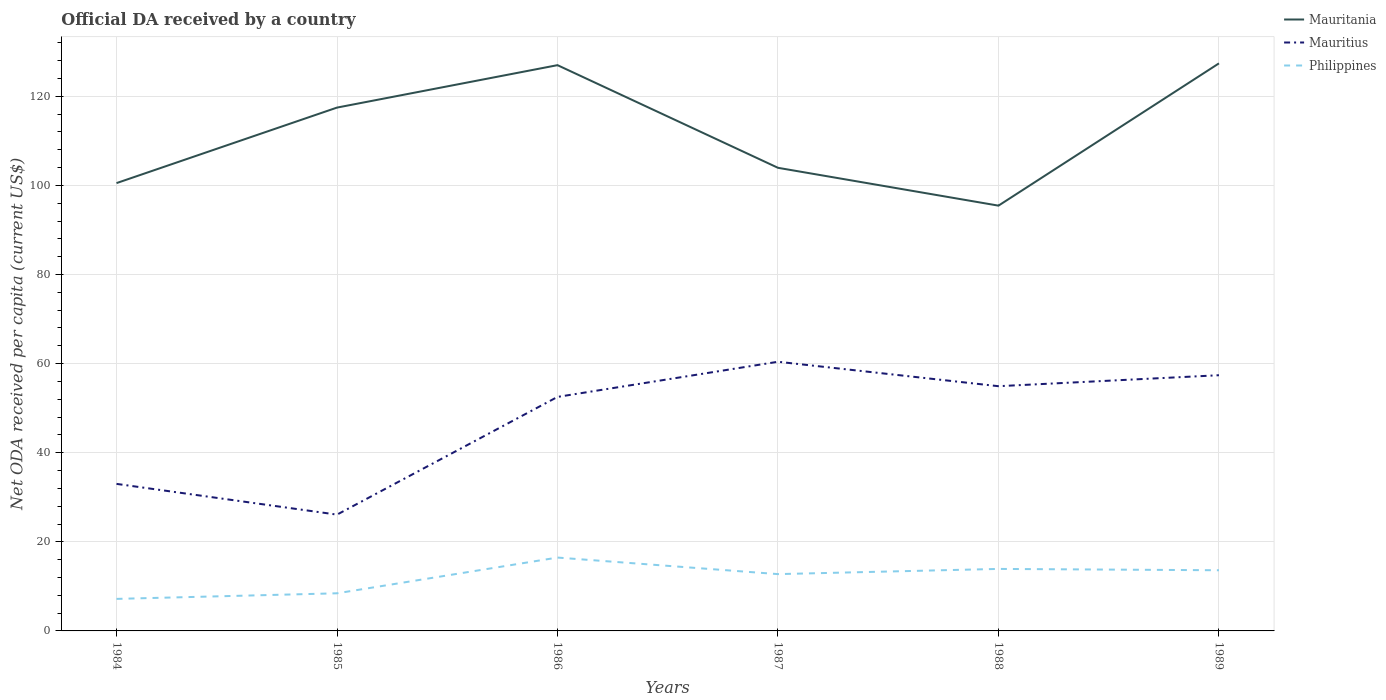Is the number of lines equal to the number of legend labels?
Ensure brevity in your answer.  Yes. Across all years, what is the maximum ODA received in in Mauritius?
Offer a terse response. 26.1. In which year was the ODA received in in Mauritius maximum?
Make the answer very short. 1985. What is the total ODA received in in Mauritius in the graph?
Provide a short and direct response. -31.29. What is the difference between the highest and the second highest ODA received in in Mauritania?
Ensure brevity in your answer.  31.94. How many years are there in the graph?
Give a very brief answer. 6. Are the values on the major ticks of Y-axis written in scientific E-notation?
Provide a short and direct response. No. Where does the legend appear in the graph?
Offer a terse response. Top right. How many legend labels are there?
Make the answer very short. 3. How are the legend labels stacked?
Your answer should be very brief. Vertical. What is the title of the graph?
Give a very brief answer. Official DA received by a country. What is the label or title of the X-axis?
Offer a terse response. Years. What is the label or title of the Y-axis?
Give a very brief answer. Net ODA received per capita (current US$). What is the Net ODA received per capita (current US$) in Mauritania in 1984?
Ensure brevity in your answer.  100.52. What is the Net ODA received per capita (current US$) of Mauritius in 1984?
Give a very brief answer. 33.01. What is the Net ODA received per capita (current US$) of Philippines in 1984?
Your answer should be compact. 7.19. What is the Net ODA received per capita (current US$) of Mauritania in 1985?
Give a very brief answer. 117.47. What is the Net ODA received per capita (current US$) in Mauritius in 1985?
Ensure brevity in your answer.  26.1. What is the Net ODA received per capita (current US$) of Philippines in 1985?
Offer a terse response. 8.45. What is the Net ODA received per capita (current US$) of Mauritania in 1986?
Your answer should be compact. 127. What is the Net ODA received per capita (current US$) of Mauritius in 1986?
Provide a short and direct response. 52.53. What is the Net ODA received per capita (current US$) in Philippines in 1986?
Your answer should be compact. 16.47. What is the Net ODA received per capita (current US$) of Mauritania in 1987?
Give a very brief answer. 103.95. What is the Net ODA received per capita (current US$) of Mauritius in 1987?
Provide a short and direct response. 60.42. What is the Net ODA received per capita (current US$) of Philippines in 1987?
Ensure brevity in your answer.  12.75. What is the Net ODA received per capita (current US$) of Mauritania in 1988?
Your answer should be compact. 95.46. What is the Net ODA received per capita (current US$) of Mauritius in 1988?
Give a very brief answer. 54.93. What is the Net ODA received per capita (current US$) of Philippines in 1988?
Provide a succinct answer. 13.92. What is the Net ODA received per capita (current US$) of Mauritania in 1989?
Your answer should be compact. 127.4. What is the Net ODA received per capita (current US$) in Mauritius in 1989?
Make the answer very short. 57.4. What is the Net ODA received per capita (current US$) in Philippines in 1989?
Your response must be concise. 13.62. Across all years, what is the maximum Net ODA received per capita (current US$) in Mauritania?
Provide a short and direct response. 127.4. Across all years, what is the maximum Net ODA received per capita (current US$) in Mauritius?
Offer a terse response. 60.42. Across all years, what is the maximum Net ODA received per capita (current US$) in Philippines?
Offer a very short reply. 16.47. Across all years, what is the minimum Net ODA received per capita (current US$) of Mauritania?
Offer a terse response. 95.46. Across all years, what is the minimum Net ODA received per capita (current US$) of Mauritius?
Your answer should be compact. 26.1. Across all years, what is the minimum Net ODA received per capita (current US$) in Philippines?
Your answer should be very brief. 7.19. What is the total Net ODA received per capita (current US$) of Mauritania in the graph?
Provide a short and direct response. 671.81. What is the total Net ODA received per capita (current US$) in Mauritius in the graph?
Give a very brief answer. 284.39. What is the total Net ODA received per capita (current US$) of Philippines in the graph?
Your answer should be compact. 72.39. What is the difference between the Net ODA received per capita (current US$) in Mauritania in 1984 and that in 1985?
Your answer should be compact. -16.95. What is the difference between the Net ODA received per capita (current US$) of Mauritius in 1984 and that in 1985?
Offer a very short reply. 6.9. What is the difference between the Net ODA received per capita (current US$) in Philippines in 1984 and that in 1985?
Offer a very short reply. -1.26. What is the difference between the Net ODA received per capita (current US$) of Mauritania in 1984 and that in 1986?
Make the answer very short. -26.48. What is the difference between the Net ODA received per capita (current US$) of Mauritius in 1984 and that in 1986?
Ensure brevity in your answer.  -19.52. What is the difference between the Net ODA received per capita (current US$) in Philippines in 1984 and that in 1986?
Give a very brief answer. -9.28. What is the difference between the Net ODA received per capita (current US$) in Mauritania in 1984 and that in 1987?
Make the answer very short. -3.43. What is the difference between the Net ODA received per capita (current US$) in Mauritius in 1984 and that in 1987?
Give a very brief answer. -27.41. What is the difference between the Net ODA received per capita (current US$) in Philippines in 1984 and that in 1987?
Keep it short and to the point. -5.56. What is the difference between the Net ODA received per capita (current US$) of Mauritania in 1984 and that in 1988?
Offer a terse response. 5.06. What is the difference between the Net ODA received per capita (current US$) in Mauritius in 1984 and that in 1988?
Provide a succinct answer. -21.93. What is the difference between the Net ODA received per capita (current US$) of Philippines in 1984 and that in 1988?
Give a very brief answer. -6.73. What is the difference between the Net ODA received per capita (current US$) in Mauritania in 1984 and that in 1989?
Make the answer very short. -26.88. What is the difference between the Net ODA received per capita (current US$) in Mauritius in 1984 and that in 1989?
Your answer should be very brief. -24.39. What is the difference between the Net ODA received per capita (current US$) of Philippines in 1984 and that in 1989?
Provide a succinct answer. -6.43. What is the difference between the Net ODA received per capita (current US$) in Mauritania in 1985 and that in 1986?
Your response must be concise. -9.52. What is the difference between the Net ODA received per capita (current US$) of Mauritius in 1985 and that in 1986?
Provide a short and direct response. -26.43. What is the difference between the Net ODA received per capita (current US$) of Philippines in 1985 and that in 1986?
Provide a succinct answer. -8.02. What is the difference between the Net ODA received per capita (current US$) in Mauritania in 1985 and that in 1987?
Your answer should be compact. 13.52. What is the difference between the Net ODA received per capita (current US$) in Mauritius in 1985 and that in 1987?
Your response must be concise. -34.32. What is the difference between the Net ODA received per capita (current US$) of Philippines in 1985 and that in 1987?
Your answer should be very brief. -4.31. What is the difference between the Net ODA received per capita (current US$) of Mauritania in 1985 and that in 1988?
Provide a succinct answer. 22.01. What is the difference between the Net ODA received per capita (current US$) in Mauritius in 1985 and that in 1988?
Offer a terse response. -28.83. What is the difference between the Net ODA received per capita (current US$) of Philippines in 1985 and that in 1988?
Make the answer very short. -5.47. What is the difference between the Net ODA received per capita (current US$) in Mauritania in 1985 and that in 1989?
Keep it short and to the point. -9.93. What is the difference between the Net ODA received per capita (current US$) in Mauritius in 1985 and that in 1989?
Make the answer very short. -31.29. What is the difference between the Net ODA received per capita (current US$) in Philippines in 1985 and that in 1989?
Give a very brief answer. -5.17. What is the difference between the Net ODA received per capita (current US$) of Mauritania in 1986 and that in 1987?
Offer a terse response. 23.05. What is the difference between the Net ODA received per capita (current US$) in Mauritius in 1986 and that in 1987?
Offer a very short reply. -7.89. What is the difference between the Net ODA received per capita (current US$) of Philippines in 1986 and that in 1987?
Offer a terse response. 3.72. What is the difference between the Net ODA received per capita (current US$) of Mauritania in 1986 and that in 1988?
Your answer should be very brief. 31.54. What is the difference between the Net ODA received per capita (current US$) in Mauritius in 1986 and that in 1988?
Keep it short and to the point. -2.4. What is the difference between the Net ODA received per capita (current US$) in Philippines in 1986 and that in 1988?
Give a very brief answer. 2.55. What is the difference between the Net ODA received per capita (current US$) in Mauritania in 1986 and that in 1989?
Your answer should be compact. -0.4. What is the difference between the Net ODA received per capita (current US$) of Mauritius in 1986 and that in 1989?
Ensure brevity in your answer.  -4.87. What is the difference between the Net ODA received per capita (current US$) of Philippines in 1986 and that in 1989?
Give a very brief answer. 2.85. What is the difference between the Net ODA received per capita (current US$) in Mauritania in 1987 and that in 1988?
Your answer should be compact. 8.49. What is the difference between the Net ODA received per capita (current US$) in Mauritius in 1987 and that in 1988?
Your answer should be compact. 5.49. What is the difference between the Net ODA received per capita (current US$) in Philippines in 1987 and that in 1988?
Keep it short and to the point. -1.17. What is the difference between the Net ODA received per capita (current US$) of Mauritania in 1987 and that in 1989?
Your answer should be very brief. -23.45. What is the difference between the Net ODA received per capita (current US$) in Mauritius in 1987 and that in 1989?
Ensure brevity in your answer.  3.02. What is the difference between the Net ODA received per capita (current US$) of Philippines in 1987 and that in 1989?
Ensure brevity in your answer.  -0.87. What is the difference between the Net ODA received per capita (current US$) in Mauritania in 1988 and that in 1989?
Give a very brief answer. -31.94. What is the difference between the Net ODA received per capita (current US$) of Mauritius in 1988 and that in 1989?
Offer a very short reply. -2.46. What is the difference between the Net ODA received per capita (current US$) in Philippines in 1988 and that in 1989?
Give a very brief answer. 0.3. What is the difference between the Net ODA received per capita (current US$) of Mauritania in 1984 and the Net ODA received per capita (current US$) of Mauritius in 1985?
Offer a terse response. 74.42. What is the difference between the Net ODA received per capita (current US$) in Mauritania in 1984 and the Net ODA received per capita (current US$) in Philippines in 1985?
Give a very brief answer. 92.08. What is the difference between the Net ODA received per capita (current US$) of Mauritius in 1984 and the Net ODA received per capita (current US$) of Philippines in 1985?
Provide a short and direct response. 24.56. What is the difference between the Net ODA received per capita (current US$) of Mauritania in 1984 and the Net ODA received per capita (current US$) of Mauritius in 1986?
Provide a short and direct response. 47.99. What is the difference between the Net ODA received per capita (current US$) of Mauritania in 1984 and the Net ODA received per capita (current US$) of Philippines in 1986?
Make the answer very short. 84.05. What is the difference between the Net ODA received per capita (current US$) in Mauritius in 1984 and the Net ODA received per capita (current US$) in Philippines in 1986?
Provide a succinct answer. 16.54. What is the difference between the Net ODA received per capita (current US$) in Mauritania in 1984 and the Net ODA received per capita (current US$) in Mauritius in 1987?
Keep it short and to the point. 40.1. What is the difference between the Net ODA received per capita (current US$) in Mauritania in 1984 and the Net ODA received per capita (current US$) in Philippines in 1987?
Offer a terse response. 87.77. What is the difference between the Net ODA received per capita (current US$) of Mauritius in 1984 and the Net ODA received per capita (current US$) of Philippines in 1987?
Keep it short and to the point. 20.26. What is the difference between the Net ODA received per capita (current US$) of Mauritania in 1984 and the Net ODA received per capita (current US$) of Mauritius in 1988?
Give a very brief answer. 45.59. What is the difference between the Net ODA received per capita (current US$) of Mauritania in 1984 and the Net ODA received per capita (current US$) of Philippines in 1988?
Provide a succinct answer. 86.6. What is the difference between the Net ODA received per capita (current US$) of Mauritius in 1984 and the Net ODA received per capita (current US$) of Philippines in 1988?
Provide a succinct answer. 19.09. What is the difference between the Net ODA received per capita (current US$) of Mauritania in 1984 and the Net ODA received per capita (current US$) of Mauritius in 1989?
Ensure brevity in your answer.  43.12. What is the difference between the Net ODA received per capita (current US$) in Mauritania in 1984 and the Net ODA received per capita (current US$) in Philippines in 1989?
Your response must be concise. 86.9. What is the difference between the Net ODA received per capita (current US$) of Mauritius in 1984 and the Net ODA received per capita (current US$) of Philippines in 1989?
Your answer should be very brief. 19.39. What is the difference between the Net ODA received per capita (current US$) of Mauritania in 1985 and the Net ODA received per capita (current US$) of Mauritius in 1986?
Your answer should be very brief. 64.94. What is the difference between the Net ODA received per capita (current US$) of Mauritania in 1985 and the Net ODA received per capita (current US$) of Philippines in 1986?
Provide a succinct answer. 101.01. What is the difference between the Net ODA received per capita (current US$) of Mauritius in 1985 and the Net ODA received per capita (current US$) of Philippines in 1986?
Your response must be concise. 9.64. What is the difference between the Net ODA received per capita (current US$) of Mauritania in 1985 and the Net ODA received per capita (current US$) of Mauritius in 1987?
Give a very brief answer. 57.05. What is the difference between the Net ODA received per capita (current US$) in Mauritania in 1985 and the Net ODA received per capita (current US$) in Philippines in 1987?
Your response must be concise. 104.72. What is the difference between the Net ODA received per capita (current US$) of Mauritius in 1985 and the Net ODA received per capita (current US$) of Philippines in 1987?
Offer a terse response. 13.35. What is the difference between the Net ODA received per capita (current US$) in Mauritania in 1985 and the Net ODA received per capita (current US$) in Mauritius in 1988?
Give a very brief answer. 62.54. What is the difference between the Net ODA received per capita (current US$) in Mauritania in 1985 and the Net ODA received per capita (current US$) in Philippines in 1988?
Your response must be concise. 103.55. What is the difference between the Net ODA received per capita (current US$) of Mauritius in 1985 and the Net ODA received per capita (current US$) of Philippines in 1988?
Your answer should be compact. 12.18. What is the difference between the Net ODA received per capita (current US$) of Mauritania in 1985 and the Net ODA received per capita (current US$) of Mauritius in 1989?
Offer a terse response. 60.08. What is the difference between the Net ODA received per capita (current US$) of Mauritania in 1985 and the Net ODA received per capita (current US$) of Philippines in 1989?
Ensure brevity in your answer.  103.86. What is the difference between the Net ODA received per capita (current US$) of Mauritius in 1985 and the Net ODA received per capita (current US$) of Philippines in 1989?
Provide a succinct answer. 12.49. What is the difference between the Net ODA received per capita (current US$) of Mauritania in 1986 and the Net ODA received per capita (current US$) of Mauritius in 1987?
Your answer should be very brief. 66.58. What is the difference between the Net ODA received per capita (current US$) in Mauritania in 1986 and the Net ODA received per capita (current US$) in Philippines in 1987?
Make the answer very short. 114.25. What is the difference between the Net ODA received per capita (current US$) of Mauritius in 1986 and the Net ODA received per capita (current US$) of Philippines in 1987?
Offer a terse response. 39.78. What is the difference between the Net ODA received per capita (current US$) of Mauritania in 1986 and the Net ODA received per capita (current US$) of Mauritius in 1988?
Make the answer very short. 72.06. What is the difference between the Net ODA received per capita (current US$) in Mauritania in 1986 and the Net ODA received per capita (current US$) in Philippines in 1988?
Offer a very short reply. 113.08. What is the difference between the Net ODA received per capita (current US$) in Mauritius in 1986 and the Net ODA received per capita (current US$) in Philippines in 1988?
Provide a succinct answer. 38.61. What is the difference between the Net ODA received per capita (current US$) in Mauritania in 1986 and the Net ODA received per capita (current US$) in Mauritius in 1989?
Provide a short and direct response. 69.6. What is the difference between the Net ODA received per capita (current US$) in Mauritania in 1986 and the Net ODA received per capita (current US$) in Philippines in 1989?
Provide a succinct answer. 113.38. What is the difference between the Net ODA received per capita (current US$) in Mauritius in 1986 and the Net ODA received per capita (current US$) in Philippines in 1989?
Provide a succinct answer. 38.91. What is the difference between the Net ODA received per capita (current US$) of Mauritania in 1987 and the Net ODA received per capita (current US$) of Mauritius in 1988?
Your answer should be very brief. 49.02. What is the difference between the Net ODA received per capita (current US$) in Mauritania in 1987 and the Net ODA received per capita (current US$) in Philippines in 1988?
Offer a very short reply. 90.03. What is the difference between the Net ODA received per capita (current US$) of Mauritius in 1987 and the Net ODA received per capita (current US$) of Philippines in 1988?
Your answer should be compact. 46.5. What is the difference between the Net ODA received per capita (current US$) of Mauritania in 1987 and the Net ODA received per capita (current US$) of Mauritius in 1989?
Ensure brevity in your answer.  46.56. What is the difference between the Net ODA received per capita (current US$) in Mauritania in 1987 and the Net ODA received per capita (current US$) in Philippines in 1989?
Your answer should be compact. 90.33. What is the difference between the Net ODA received per capita (current US$) of Mauritius in 1987 and the Net ODA received per capita (current US$) of Philippines in 1989?
Provide a succinct answer. 46.8. What is the difference between the Net ODA received per capita (current US$) in Mauritania in 1988 and the Net ODA received per capita (current US$) in Mauritius in 1989?
Ensure brevity in your answer.  38.07. What is the difference between the Net ODA received per capita (current US$) in Mauritania in 1988 and the Net ODA received per capita (current US$) in Philippines in 1989?
Keep it short and to the point. 81.84. What is the difference between the Net ODA received per capita (current US$) of Mauritius in 1988 and the Net ODA received per capita (current US$) of Philippines in 1989?
Make the answer very short. 41.32. What is the average Net ODA received per capita (current US$) in Mauritania per year?
Offer a terse response. 111.97. What is the average Net ODA received per capita (current US$) of Mauritius per year?
Ensure brevity in your answer.  47.4. What is the average Net ODA received per capita (current US$) in Philippines per year?
Your answer should be compact. 12.07. In the year 1984, what is the difference between the Net ODA received per capita (current US$) in Mauritania and Net ODA received per capita (current US$) in Mauritius?
Offer a terse response. 67.51. In the year 1984, what is the difference between the Net ODA received per capita (current US$) of Mauritania and Net ODA received per capita (current US$) of Philippines?
Provide a succinct answer. 93.33. In the year 1984, what is the difference between the Net ODA received per capita (current US$) in Mauritius and Net ODA received per capita (current US$) in Philippines?
Give a very brief answer. 25.82. In the year 1985, what is the difference between the Net ODA received per capita (current US$) of Mauritania and Net ODA received per capita (current US$) of Mauritius?
Offer a very short reply. 91.37. In the year 1985, what is the difference between the Net ODA received per capita (current US$) in Mauritania and Net ODA received per capita (current US$) in Philippines?
Your answer should be compact. 109.03. In the year 1985, what is the difference between the Net ODA received per capita (current US$) in Mauritius and Net ODA received per capita (current US$) in Philippines?
Keep it short and to the point. 17.66. In the year 1986, what is the difference between the Net ODA received per capita (current US$) in Mauritania and Net ODA received per capita (current US$) in Mauritius?
Offer a very short reply. 74.47. In the year 1986, what is the difference between the Net ODA received per capita (current US$) in Mauritania and Net ODA received per capita (current US$) in Philippines?
Make the answer very short. 110.53. In the year 1986, what is the difference between the Net ODA received per capita (current US$) in Mauritius and Net ODA received per capita (current US$) in Philippines?
Your response must be concise. 36.06. In the year 1987, what is the difference between the Net ODA received per capita (current US$) of Mauritania and Net ODA received per capita (current US$) of Mauritius?
Provide a short and direct response. 43.53. In the year 1987, what is the difference between the Net ODA received per capita (current US$) in Mauritania and Net ODA received per capita (current US$) in Philippines?
Make the answer very short. 91.2. In the year 1987, what is the difference between the Net ODA received per capita (current US$) in Mauritius and Net ODA received per capita (current US$) in Philippines?
Give a very brief answer. 47.67. In the year 1988, what is the difference between the Net ODA received per capita (current US$) in Mauritania and Net ODA received per capita (current US$) in Mauritius?
Your answer should be very brief. 40.53. In the year 1988, what is the difference between the Net ODA received per capita (current US$) in Mauritania and Net ODA received per capita (current US$) in Philippines?
Your answer should be very brief. 81.54. In the year 1988, what is the difference between the Net ODA received per capita (current US$) in Mauritius and Net ODA received per capita (current US$) in Philippines?
Your answer should be compact. 41.02. In the year 1989, what is the difference between the Net ODA received per capita (current US$) in Mauritania and Net ODA received per capita (current US$) in Mauritius?
Make the answer very short. 70.01. In the year 1989, what is the difference between the Net ODA received per capita (current US$) in Mauritania and Net ODA received per capita (current US$) in Philippines?
Your answer should be very brief. 113.78. In the year 1989, what is the difference between the Net ODA received per capita (current US$) of Mauritius and Net ODA received per capita (current US$) of Philippines?
Offer a terse response. 43.78. What is the ratio of the Net ODA received per capita (current US$) in Mauritania in 1984 to that in 1985?
Your response must be concise. 0.86. What is the ratio of the Net ODA received per capita (current US$) in Mauritius in 1984 to that in 1985?
Ensure brevity in your answer.  1.26. What is the ratio of the Net ODA received per capita (current US$) in Philippines in 1984 to that in 1985?
Your answer should be compact. 0.85. What is the ratio of the Net ODA received per capita (current US$) in Mauritania in 1984 to that in 1986?
Offer a terse response. 0.79. What is the ratio of the Net ODA received per capita (current US$) in Mauritius in 1984 to that in 1986?
Offer a very short reply. 0.63. What is the ratio of the Net ODA received per capita (current US$) in Philippines in 1984 to that in 1986?
Provide a short and direct response. 0.44. What is the ratio of the Net ODA received per capita (current US$) in Mauritius in 1984 to that in 1987?
Your answer should be compact. 0.55. What is the ratio of the Net ODA received per capita (current US$) in Philippines in 1984 to that in 1987?
Give a very brief answer. 0.56. What is the ratio of the Net ODA received per capita (current US$) of Mauritania in 1984 to that in 1988?
Give a very brief answer. 1.05. What is the ratio of the Net ODA received per capita (current US$) of Mauritius in 1984 to that in 1988?
Provide a short and direct response. 0.6. What is the ratio of the Net ODA received per capita (current US$) in Philippines in 1984 to that in 1988?
Ensure brevity in your answer.  0.52. What is the ratio of the Net ODA received per capita (current US$) of Mauritania in 1984 to that in 1989?
Keep it short and to the point. 0.79. What is the ratio of the Net ODA received per capita (current US$) in Mauritius in 1984 to that in 1989?
Your response must be concise. 0.58. What is the ratio of the Net ODA received per capita (current US$) of Philippines in 1984 to that in 1989?
Make the answer very short. 0.53. What is the ratio of the Net ODA received per capita (current US$) in Mauritania in 1985 to that in 1986?
Your response must be concise. 0.93. What is the ratio of the Net ODA received per capita (current US$) of Mauritius in 1985 to that in 1986?
Your answer should be very brief. 0.5. What is the ratio of the Net ODA received per capita (current US$) of Philippines in 1985 to that in 1986?
Provide a succinct answer. 0.51. What is the ratio of the Net ODA received per capita (current US$) of Mauritania in 1985 to that in 1987?
Keep it short and to the point. 1.13. What is the ratio of the Net ODA received per capita (current US$) of Mauritius in 1985 to that in 1987?
Provide a short and direct response. 0.43. What is the ratio of the Net ODA received per capita (current US$) of Philippines in 1985 to that in 1987?
Your answer should be very brief. 0.66. What is the ratio of the Net ODA received per capita (current US$) in Mauritania in 1985 to that in 1988?
Offer a terse response. 1.23. What is the ratio of the Net ODA received per capita (current US$) in Mauritius in 1985 to that in 1988?
Provide a succinct answer. 0.48. What is the ratio of the Net ODA received per capita (current US$) of Philippines in 1985 to that in 1988?
Your response must be concise. 0.61. What is the ratio of the Net ODA received per capita (current US$) in Mauritania in 1985 to that in 1989?
Provide a short and direct response. 0.92. What is the ratio of the Net ODA received per capita (current US$) of Mauritius in 1985 to that in 1989?
Offer a terse response. 0.45. What is the ratio of the Net ODA received per capita (current US$) in Philippines in 1985 to that in 1989?
Ensure brevity in your answer.  0.62. What is the ratio of the Net ODA received per capita (current US$) in Mauritania in 1986 to that in 1987?
Give a very brief answer. 1.22. What is the ratio of the Net ODA received per capita (current US$) of Mauritius in 1986 to that in 1987?
Ensure brevity in your answer.  0.87. What is the ratio of the Net ODA received per capita (current US$) of Philippines in 1986 to that in 1987?
Your response must be concise. 1.29. What is the ratio of the Net ODA received per capita (current US$) of Mauritania in 1986 to that in 1988?
Ensure brevity in your answer.  1.33. What is the ratio of the Net ODA received per capita (current US$) of Mauritius in 1986 to that in 1988?
Offer a terse response. 0.96. What is the ratio of the Net ODA received per capita (current US$) of Philippines in 1986 to that in 1988?
Provide a short and direct response. 1.18. What is the ratio of the Net ODA received per capita (current US$) of Mauritius in 1986 to that in 1989?
Provide a succinct answer. 0.92. What is the ratio of the Net ODA received per capita (current US$) of Philippines in 1986 to that in 1989?
Provide a succinct answer. 1.21. What is the ratio of the Net ODA received per capita (current US$) in Mauritania in 1987 to that in 1988?
Give a very brief answer. 1.09. What is the ratio of the Net ODA received per capita (current US$) in Mauritius in 1987 to that in 1988?
Provide a succinct answer. 1.1. What is the ratio of the Net ODA received per capita (current US$) of Philippines in 1987 to that in 1988?
Your answer should be very brief. 0.92. What is the ratio of the Net ODA received per capita (current US$) in Mauritania in 1987 to that in 1989?
Keep it short and to the point. 0.82. What is the ratio of the Net ODA received per capita (current US$) of Mauritius in 1987 to that in 1989?
Your response must be concise. 1.05. What is the ratio of the Net ODA received per capita (current US$) of Philippines in 1987 to that in 1989?
Offer a very short reply. 0.94. What is the ratio of the Net ODA received per capita (current US$) of Mauritania in 1988 to that in 1989?
Provide a short and direct response. 0.75. What is the ratio of the Net ODA received per capita (current US$) of Mauritius in 1988 to that in 1989?
Offer a very short reply. 0.96. What is the ratio of the Net ODA received per capita (current US$) of Philippines in 1988 to that in 1989?
Offer a terse response. 1.02. What is the difference between the highest and the second highest Net ODA received per capita (current US$) in Mauritania?
Make the answer very short. 0.4. What is the difference between the highest and the second highest Net ODA received per capita (current US$) of Mauritius?
Give a very brief answer. 3.02. What is the difference between the highest and the second highest Net ODA received per capita (current US$) of Philippines?
Your response must be concise. 2.55. What is the difference between the highest and the lowest Net ODA received per capita (current US$) of Mauritania?
Keep it short and to the point. 31.94. What is the difference between the highest and the lowest Net ODA received per capita (current US$) of Mauritius?
Your answer should be very brief. 34.32. What is the difference between the highest and the lowest Net ODA received per capita (current US$) of Philippines?
Provide a short and direct response. 9.28. 